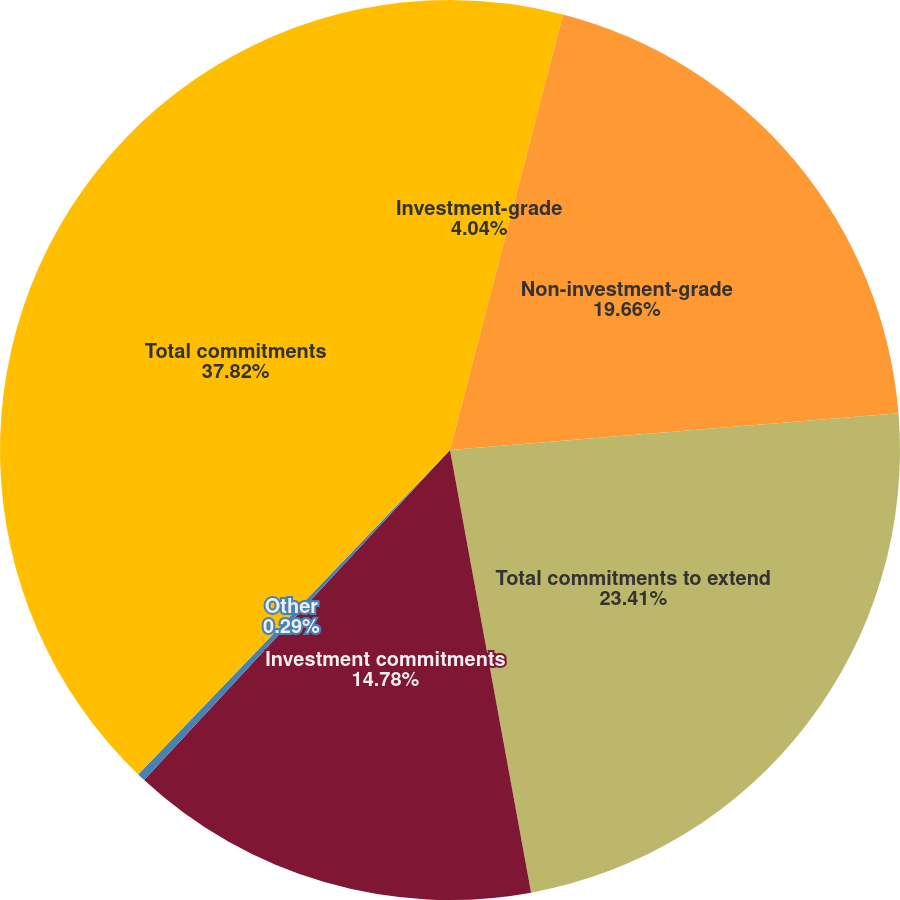<chart> <loc_0><loc_0><loc_500><loc_500><pie_chart><fcel>Investment-grade<fcel>Non-investment-grade<fcel>Total commitments to extend<fcel>Investment commitments<fcel>Other<fcel>Total commitments<nl><fcel>4.04%<fcel>19.66%<fcel>23.41%<fcel>14.78%<fcel>0.29%<fcel>37.81%<nl></chart> 